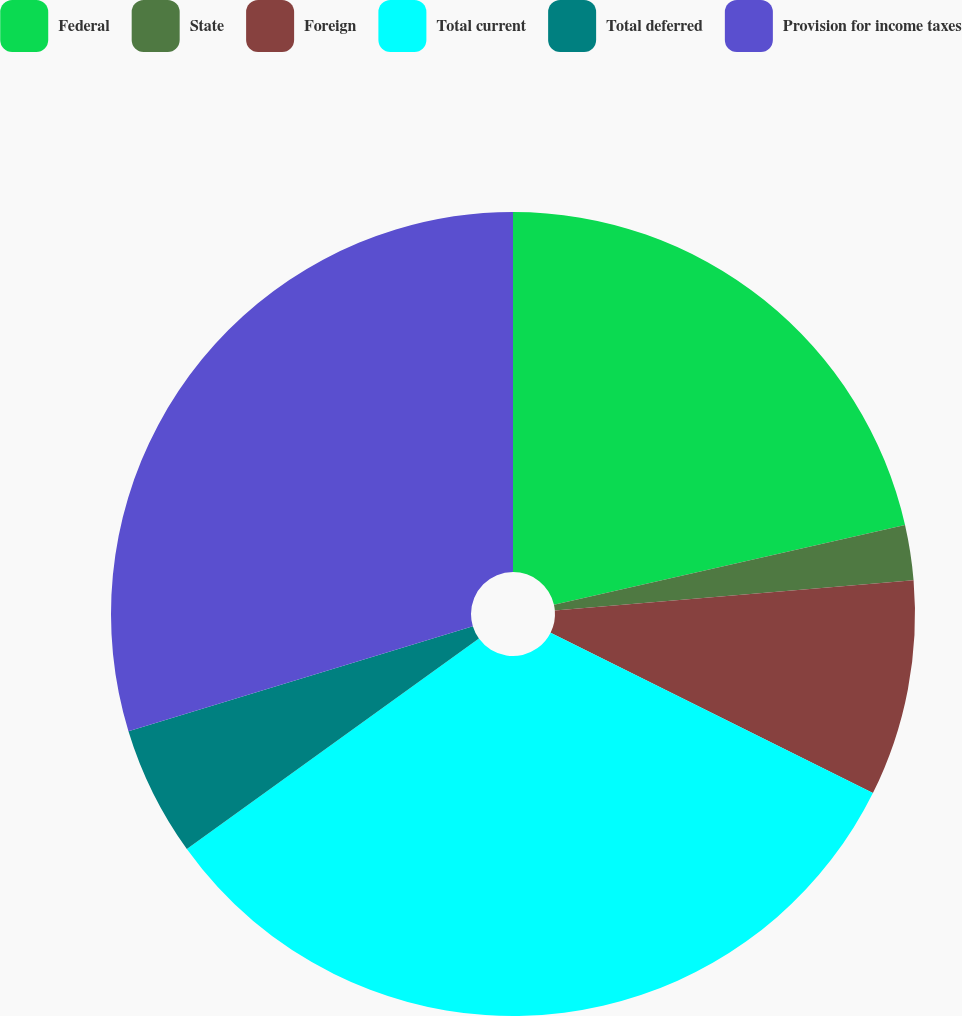Convert chart to OTSL. <chart><loc_0><loc_0><loc_500><loc_500><pie_chart><fcel>Federal<fcel>State<fcel>Foreign<fcel>Total current<fcel>Total deferred<fcel>Provision for income taxes<nl><fcel>21.45%<fcel>2.21%<fcel>8.69%<fcel>32.72%<fcel>5.23%<fcel>29.71%<nl></chart> 